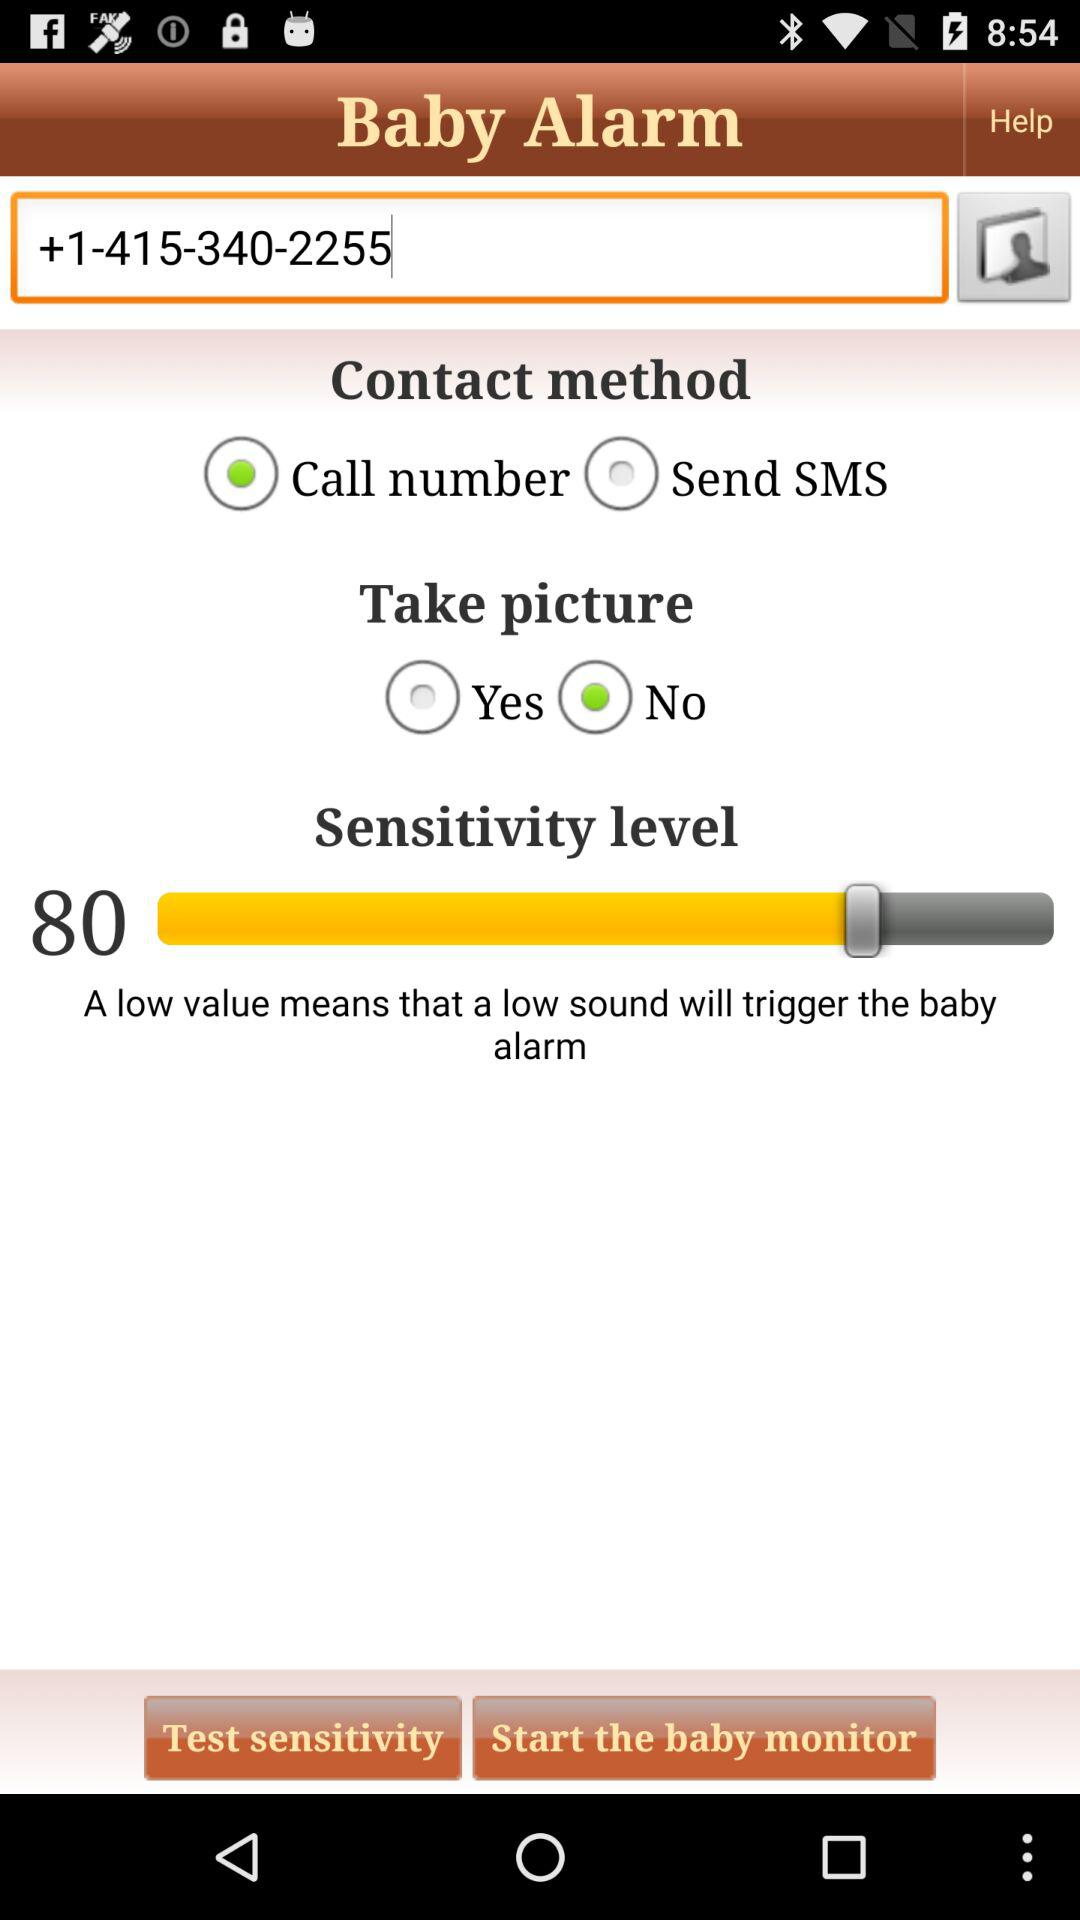What is the contact number? The contact number is +1-415-340-2255. 